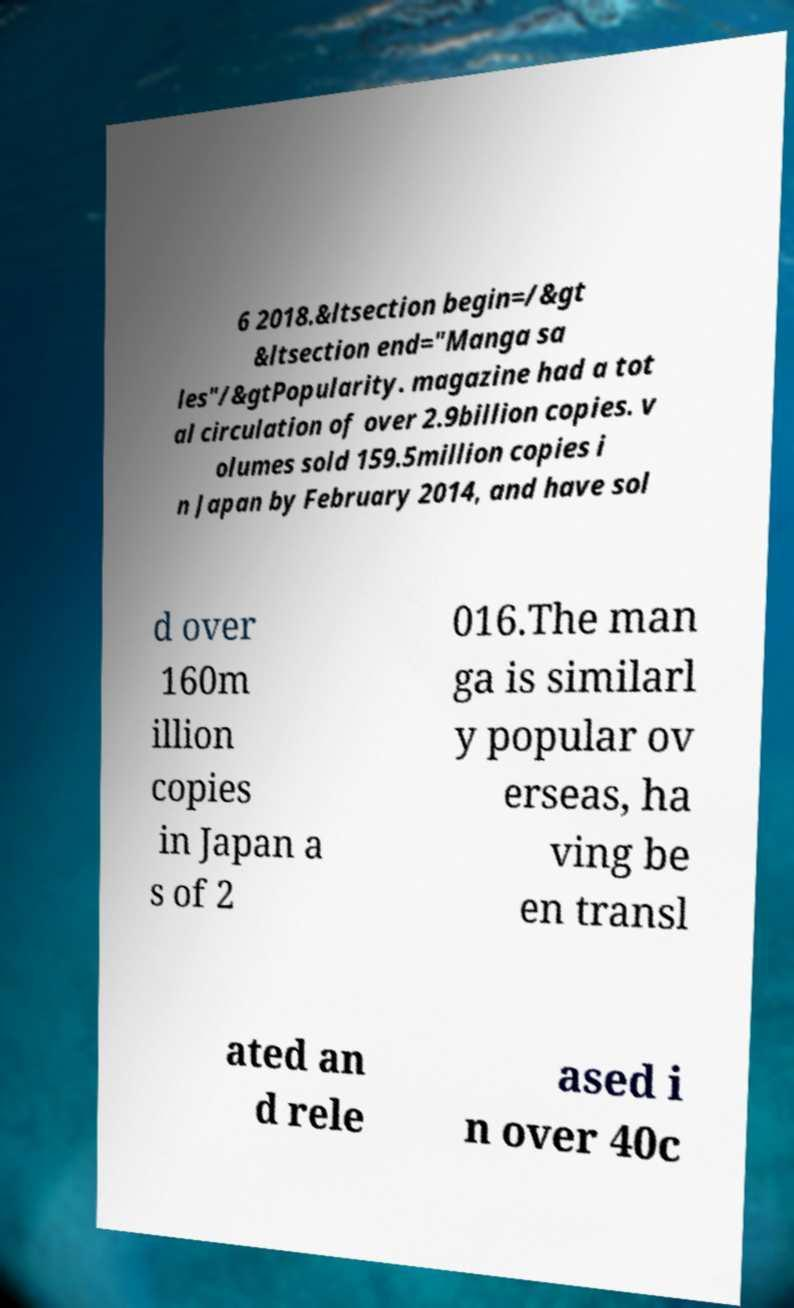Please identify and transcribe the text found in this image. 6 2018.&ltsection begin=/&gt &ltsection end="Manga sa les"/&gtPopularity. magazine had a tot al circulation of over 2.9billion copies. v olumes sold 159.5million copies i n Japan by February 2014, and have sol d over 160m illion copies in Japan a s of 2 016.The man ga is similarl y popular ov erseas, ha ving be en transl ated an d rele ased i n over 40c 